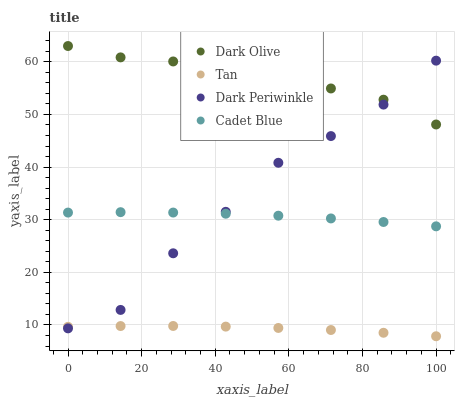Does Tan have the minimum area under the curve?
Answer yes or no. Yes. Does Dark Olive have the maximum area under the curve?
Answer yes or no. Yes. Does Dark Olive have the minimum area under the curve?
Answer yes or no. No. Does Tan have the maximum area under the curve?
Answer yes or no. No. Is Tan the smoothest?
Answer yes or no. Yes. Is Dark Periwinkle the roughest?
Answer yes or no. Yes. Is Dark Olive the smoothest?
Answer yes or no. No. Is Dark Olive the roughest?
Answer yes or no. No. Does Tan have the lowest value?
Answer yes or no. Yes. Does Dark Olive have the lowest value?
Answer yes or no. No. Does Dark Olive have the highest value?
Answer yes or no. Yes. Does Tan have the highest value?
Answer yes or no. No. Is Tan less than Cadet Blue?
Answer yes or no. Yes. Is Cadet Blue greater than Tan?
Answer yes or no. Yes. Does Cadet Blue intersect Dark Periwinkle?
Answer yes or no. Yes. Is Cadet Blue less than Dark Periwinkle?
Answer yes or no. No. Is Cadet Blue greater than Dark Periwinkle?
Answer yes or no. No. Does Tan intersect Cadet Blue?
Answer yes or no. No. 